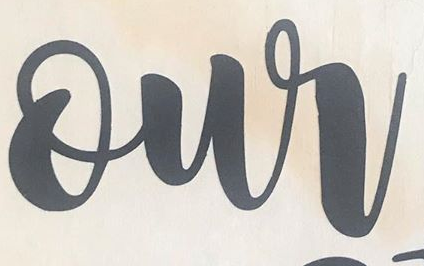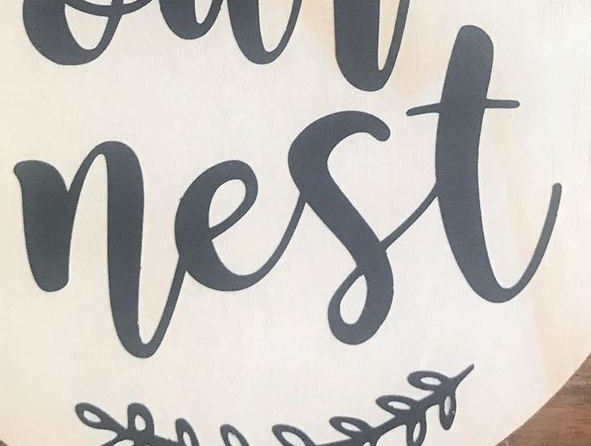What text appears in these images from left to right, separated by a semicolon? our; nest 